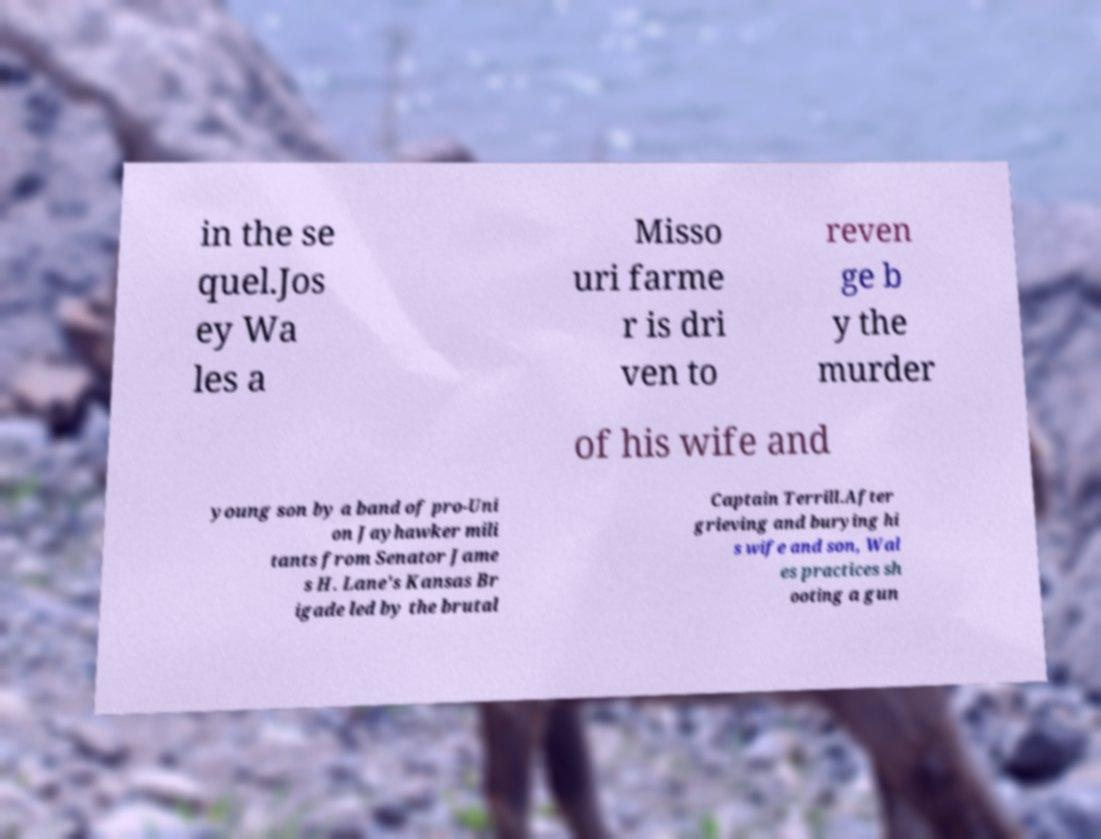Can you read and provide the text displayed in the image?This photo seems to have some interesting text. Can you extract and type it out for me? in the se quel.Jos ey Wa les a Misso uri farme r is dri ven to reven ge b y the murder of his wife and young son by a band of pro-Uni on Jayhawker mili tants from Senator Jame s H. Lane's Kansas Br igade led by the brutal Captain Terrill.After grieving and burying hi s wife and son, Wal es practices sh ooting a gun 